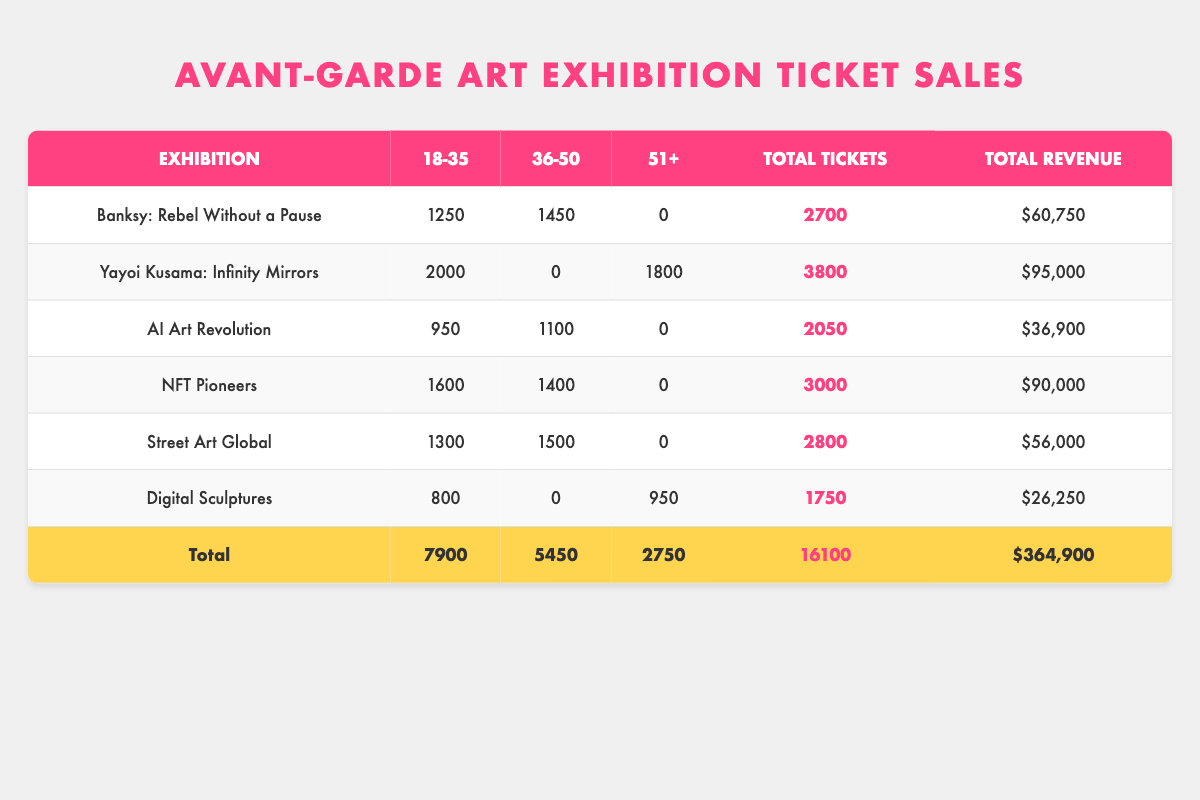What exhibition had the highest total tickets sold? Looking at the Total Tickets column, Yayoi Kusama: Infinity Mirrors has the highest value of 3800 tickets sold among all exhibitions.
Answer: Yayoi Kusama: Infinity Mirrors How many tickets were sold for Digital Sculptures in the 36-50 age group? According to the table, Digital Sculptures has 0 tickets sold in the 36-50 age group listed in the second column of that row.
Answer: 0 What is the total revenue generated from all exhibitions? The total revenue is calculated by adding up the revenue from each exhibition, which is $60,750 + $95,000 + $36,900 + $90,000 + $56,000 + $26,250 = $364,900.
Answer: $364,900 Which age group sold the most tickets overall? By adding the total tickets sold for each age group: 7900 for 18-35, 5450 for 36-50, and 2750 for 51+. The 18-35 age group has the highest total.
Answer: 18-35 Was there an exhibition where the 51+ age group sold more than 1000 tickets? The table shows that Yayoi Kusama: Infinity Mirrors sold 1800 tickets in the 51+ age group, which is more than 1000.
Answer: Yes What is the average ticket price for the exhibitions targeting the 36-50 age group? The ticket prices for the 36-50 age group exhibitions are $22.50 (Banksy: Rebel Without a Pause), $30 (NFT Pioneers), $20 (Street Art Global), and $18 (AI Art Revolution); Add them up to get $90 and divide by 3, since there are three exhibitions. The average price is $90/3 = $30.
Answer: $30 Which exhibition had the highest revenue per ticket sold? To find the highest revenue per ticket sold, we calculate revenue divided by tickets sold for each exhibition. Yayoi Kusama: Infinity Mirrors has $95,000/3800 = $25, which is the highest value after evaluating all exhibitions.
Answer: Yayoi Kusama: Infinity Mirrors Were there any exhibitions where no tickets were sold to the 36-50 age group? Digital Sculptures and Yayoi Kusama: Infinity Mirrors sold no tickets to the 36-50 age group, shown by the presence of 0 in those rows.
Answer: Yes 